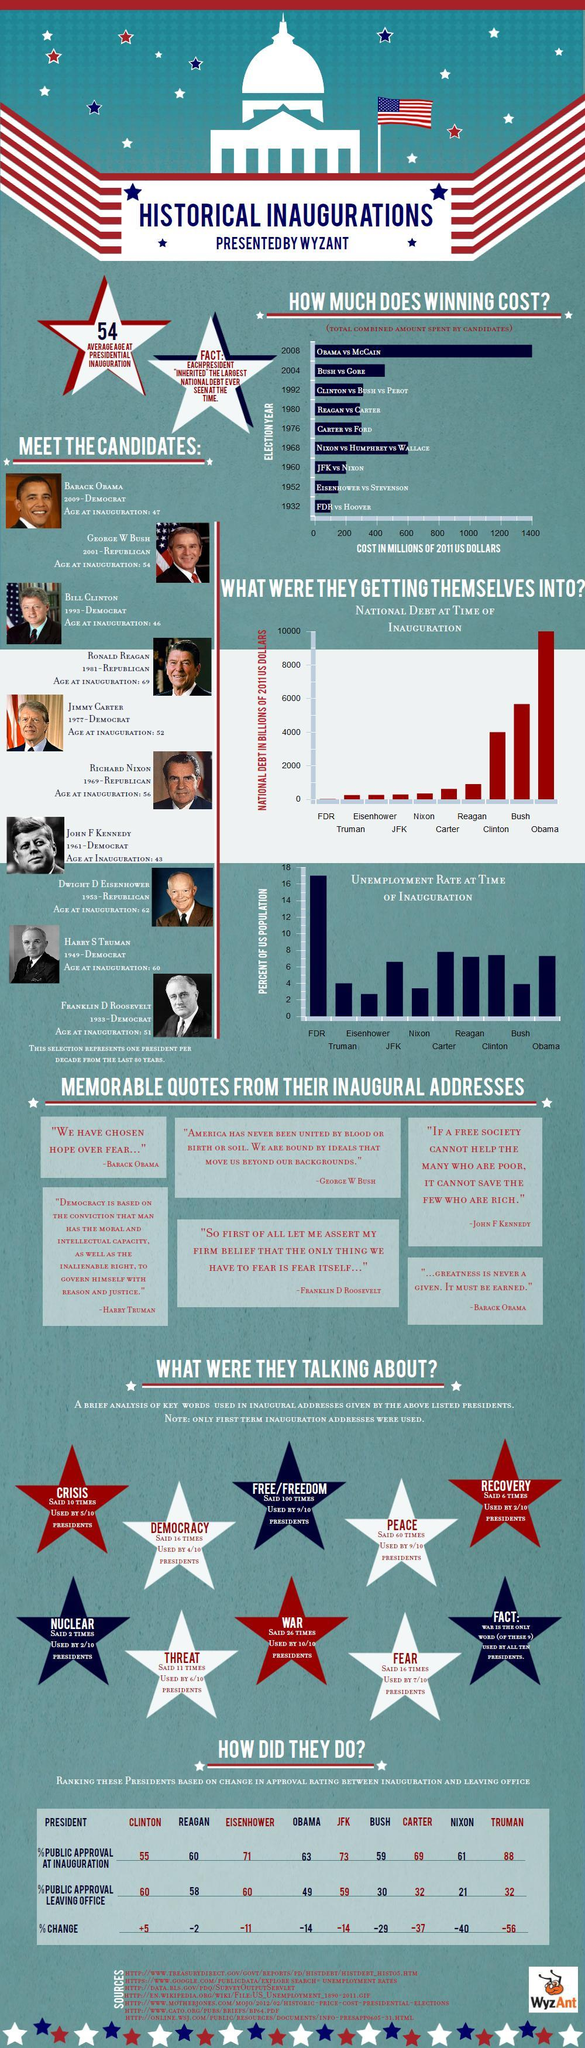What is difference in the percentage approval  at inauguration between Truman and Clinton?
Answer the question with a short phrase. 33% What is the difference in the unemployment rate during FDR and Obama's regime? 10 percent What is the difference in national debt in Billion dollars between Obama and Bush regime ? 4000 billion US dollars How many images of American Presidents are give? 10 What is the difference between the combined amount spent by Obama vs McCain and Nixon vs Humphrey vs Wallace in million US dollars? 800 million US dollars How many common keywords were used during the inaugural addresses ? 10 What is the percentage difference in public approval while leaving office between Eisenhower and Clinton ? 0 